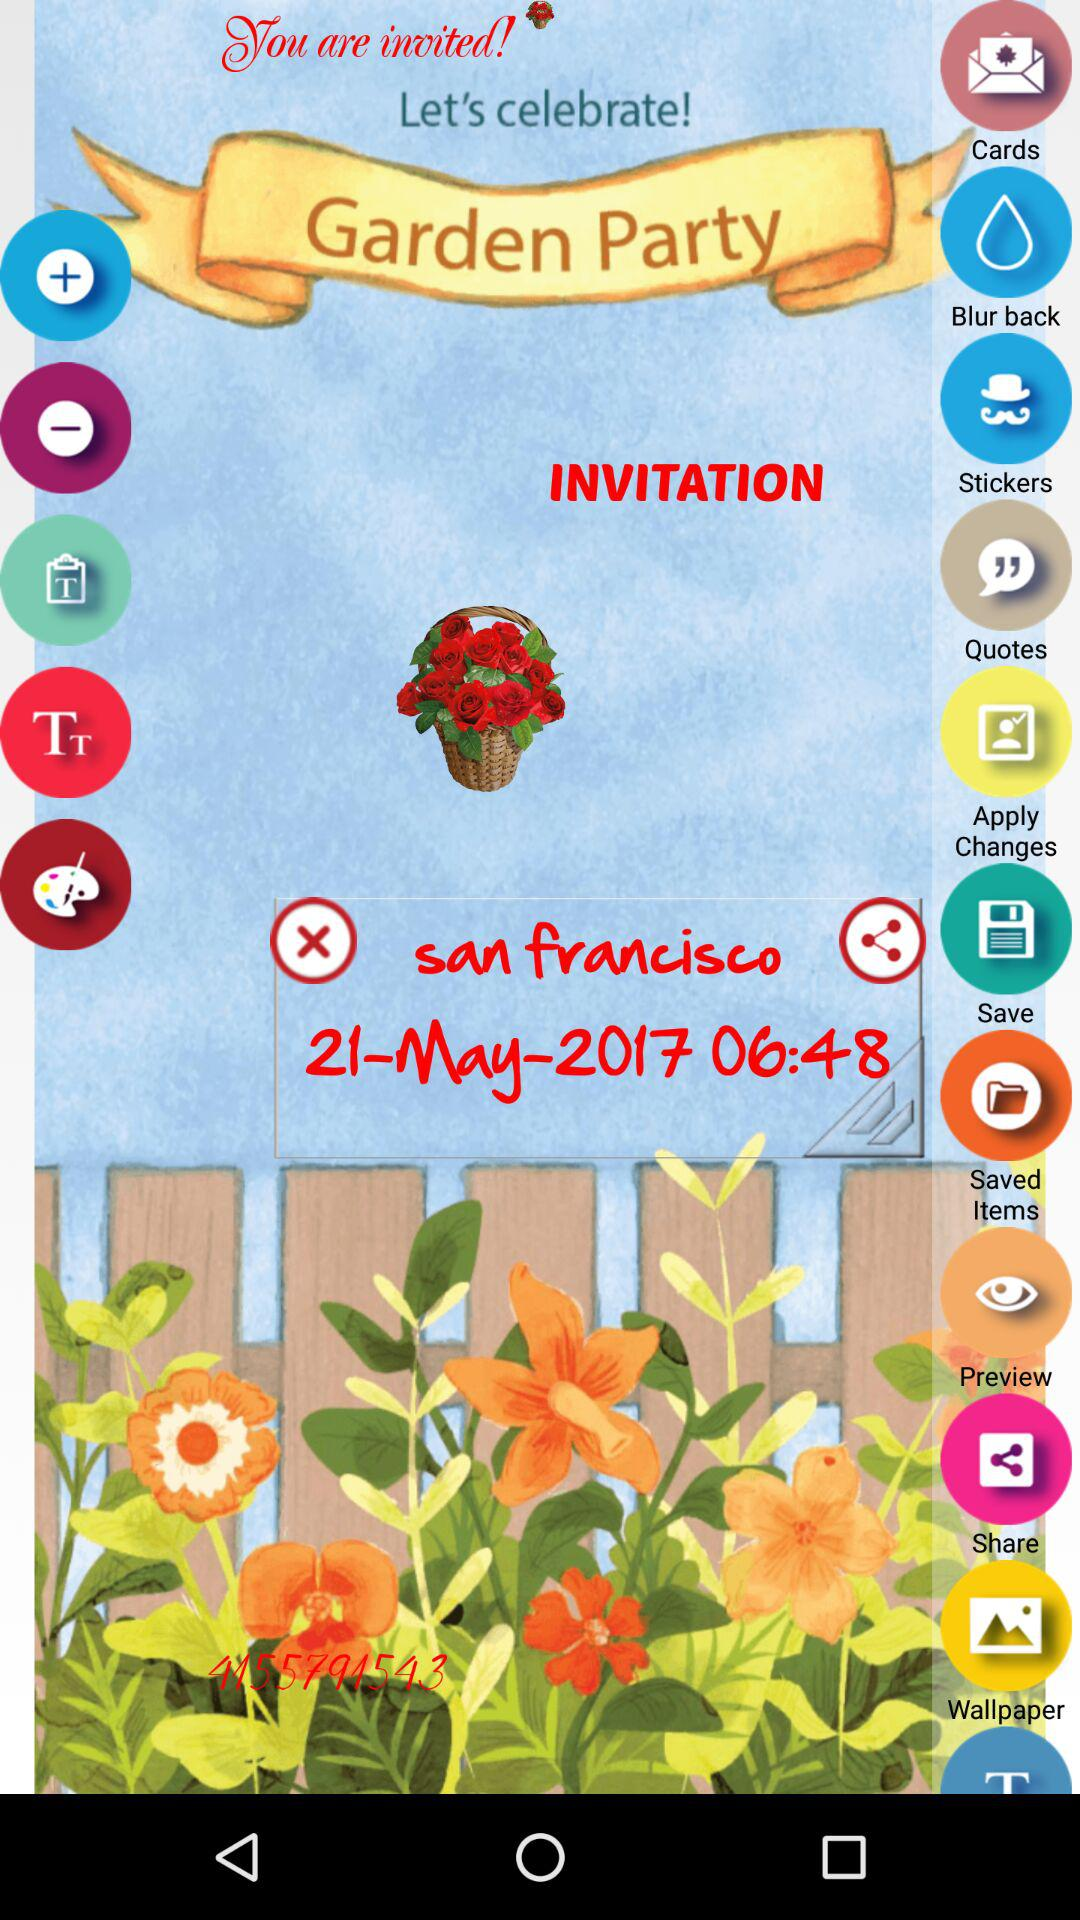What place's name is given on the screen? The given place's name is San Francisco. 